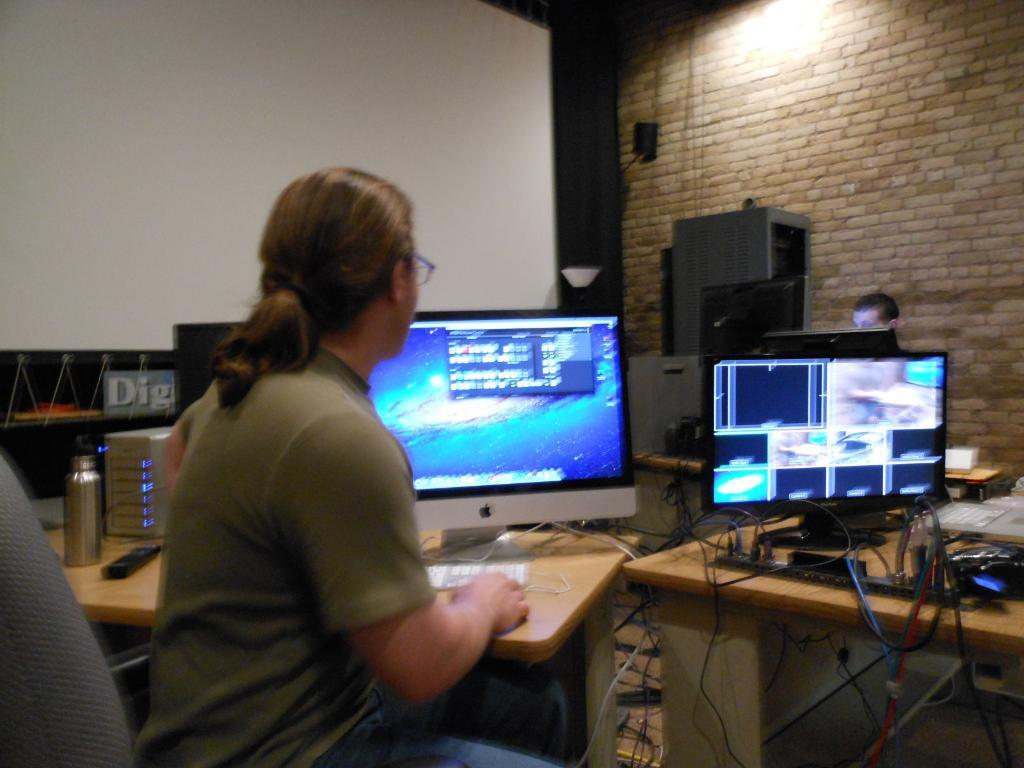Provide a one-sentence caption for the provided image. A man sits at a desk with computer screens, in front of a sign with the partial word Dig visible. 